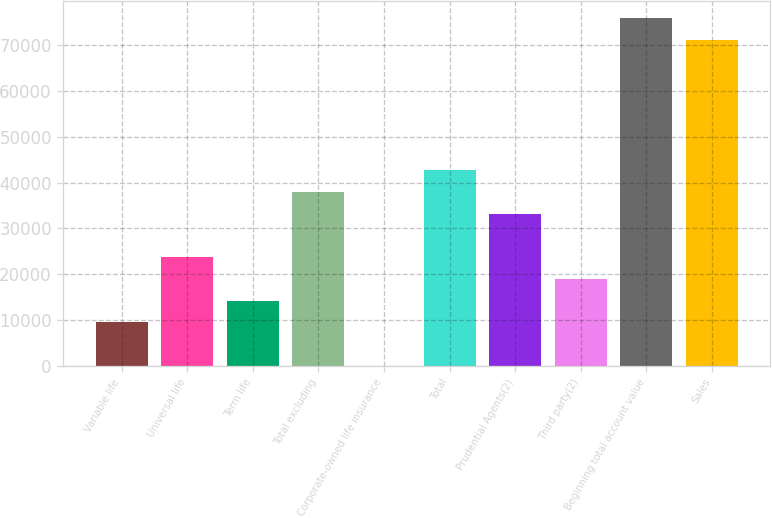Convert chart to OTSL. <chart><loc_0><loc_0><loc_500><loc_500><bar_chart><fcel>Variable life<fcel>Universal life<fcel>Term life<fcel>Total excluding<fcel>Corporate-owned life insurance<fcel>Total<fcel>Prudential Agents(2)<fcel>Third party(2)<fcel>Beginning total account value<fcel>Sales<nl><fcel>9494.8<fcel>23716<fcel>14235.2<fcel>37937.2<fcel>14<fcel>42677.6<fcel>33196.8<fcel>18975.6<fcel>75860.4<fcel>71120<nl></chart> 